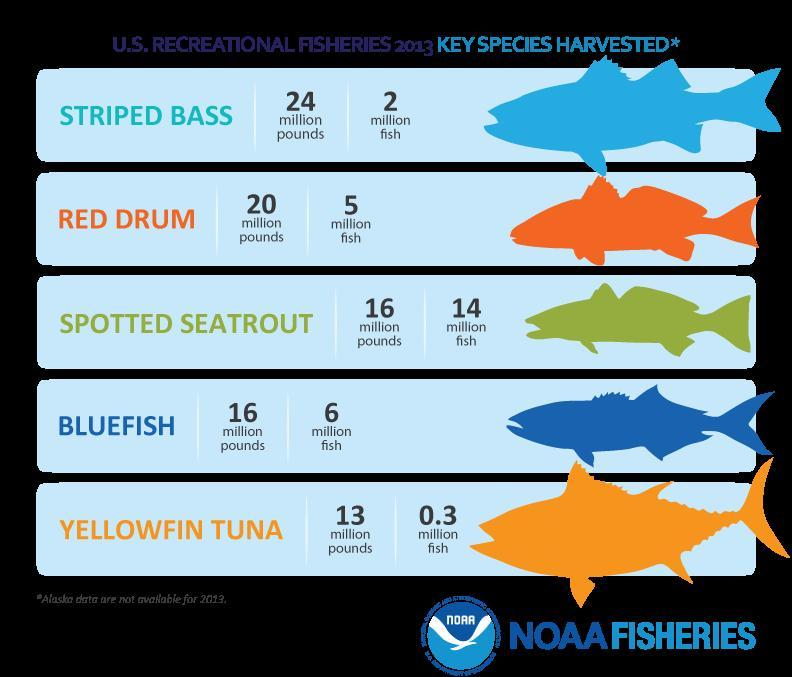How many Striped Bass are listed?
Answer the question with a short phrase. 2 million How many Red drums are there? 5 million How many Blue Fishes are there? 6 million fish How many Yellowfin Tuna is listed? 0.3 million How many Spotted Seatrouts are there? 14 million How many species are listed? 5 